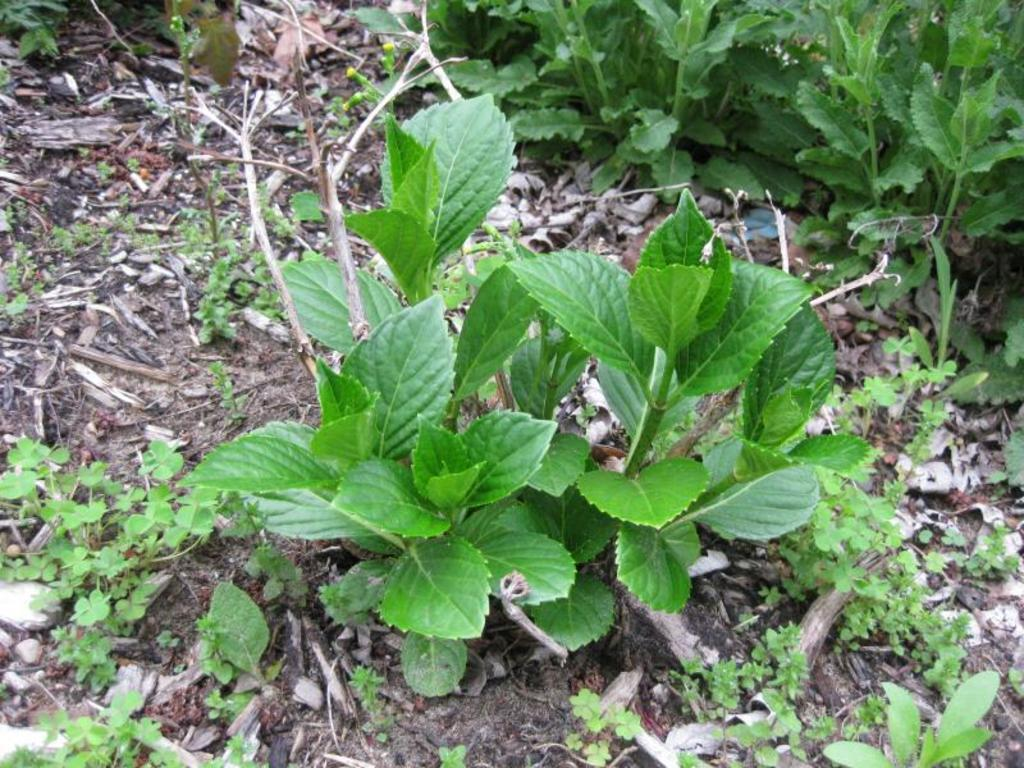What is located in the foreground of the image? There is a plant in the foreground of the image. What type of plants can be seen in the image? There are herbs and plants on the ground in the image. What type of substance is being used to make the cakes in the image? There are no cakes present in the image, so it is not possible to determine what substance might be used to make them. 